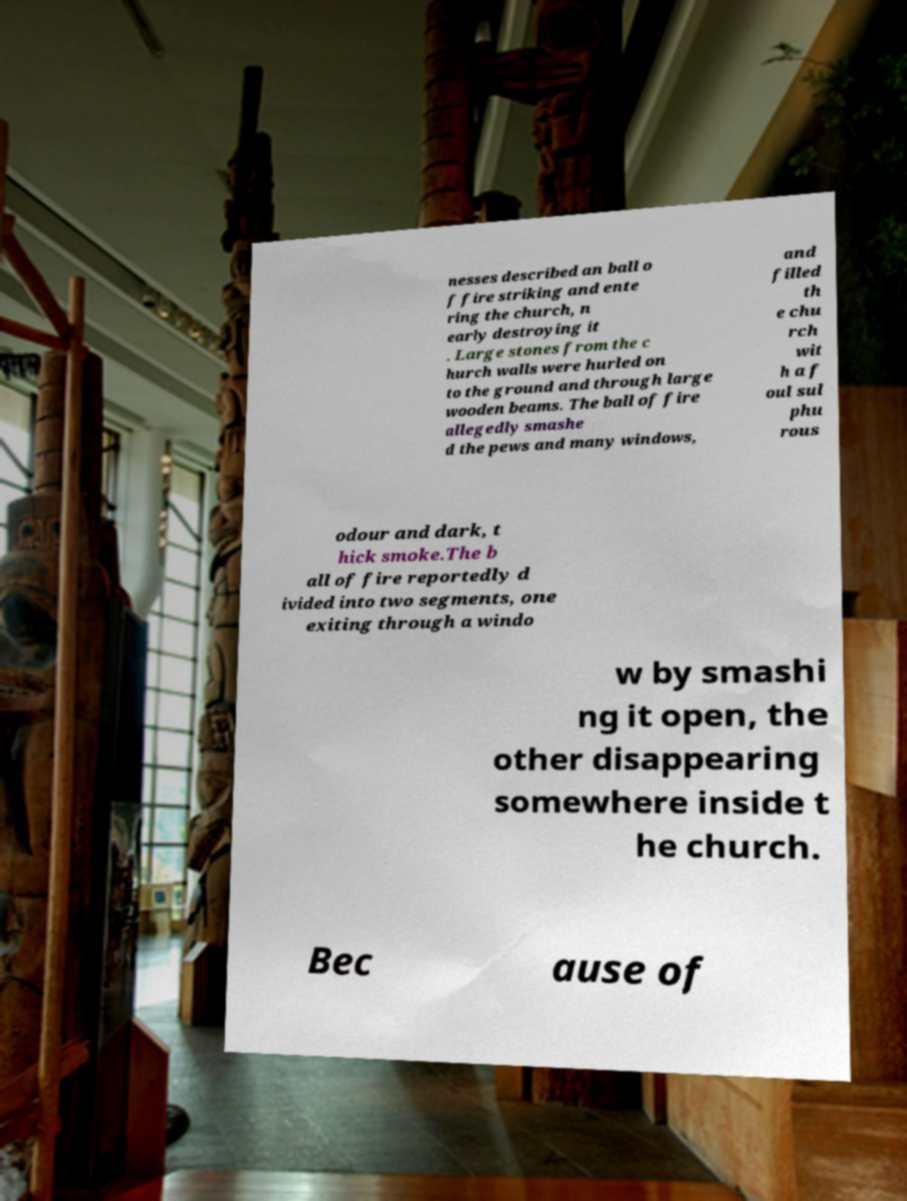There's text embedded in this image that I need extracted. Can you transcribe it verbatim? nesses described an ball o f fire striking and ente ring the church, n early destroying it . Large stones from the c hurch walls were hurled on to the ground and through large wooden beams. The ball of fire allegedly smashe d the pews and many windows, and filled th e chu rch wit h a f oul sul phu rous odour and dark, t hick smoke.The b all of fire reportedly d ivided into two segments, one exiting through a windo w by smashi ng it open, the other disappearing somewhere inside t he church. Bec ause of 